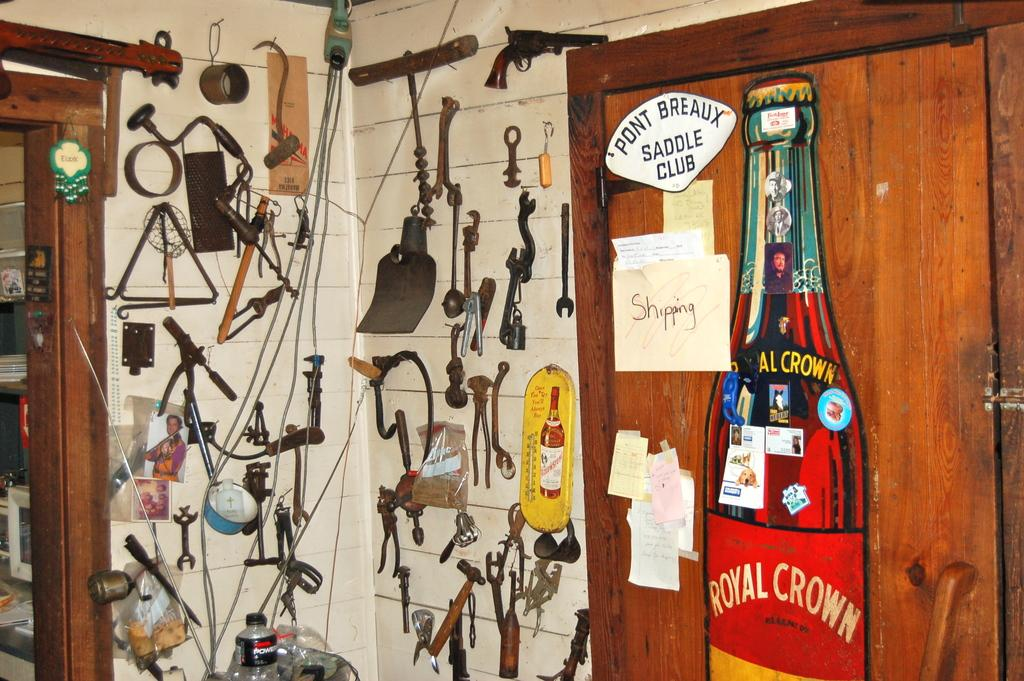<image>
Write a terse but informative summary of the picture. Several tools hanging on the wall along with a Royal Crown post on the door. 